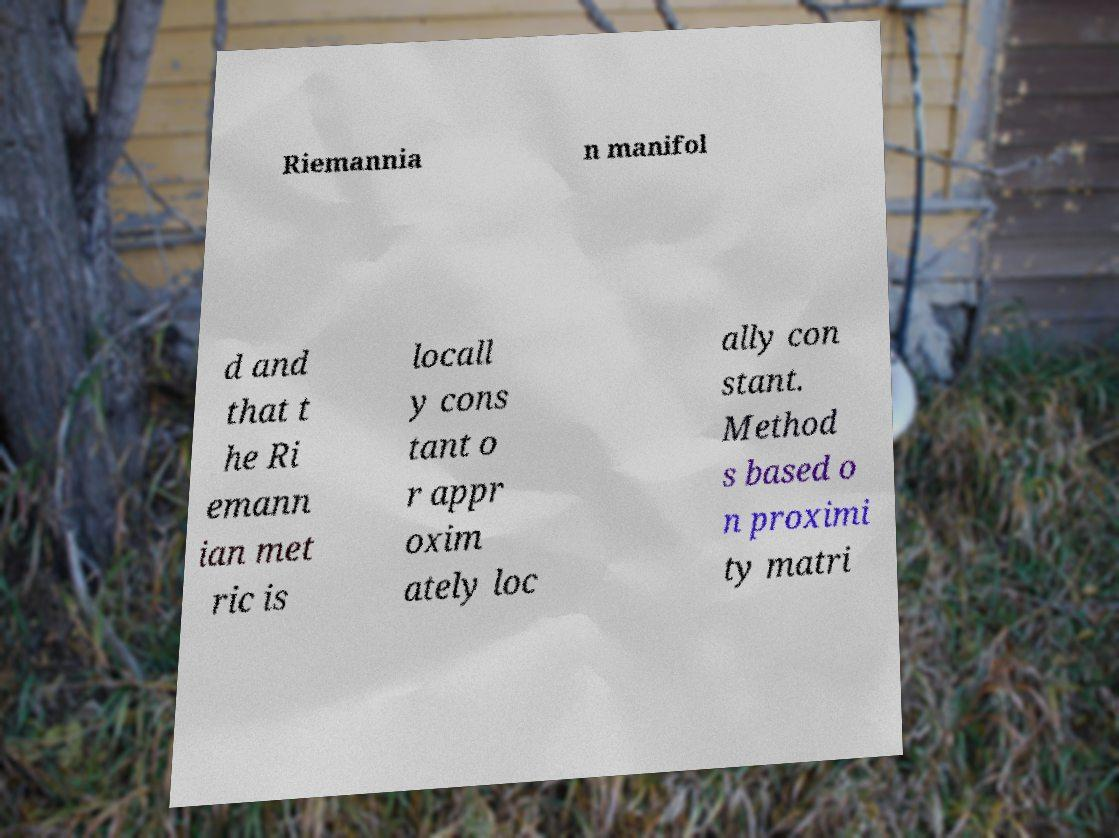Please identify and transcribe the text found in this image. Riemannia n manifol d and that t he Ri emann ian met ric is locall y cons tant o r appr oxim ately loc ally con stant. Method s based o n proximi ty matri 